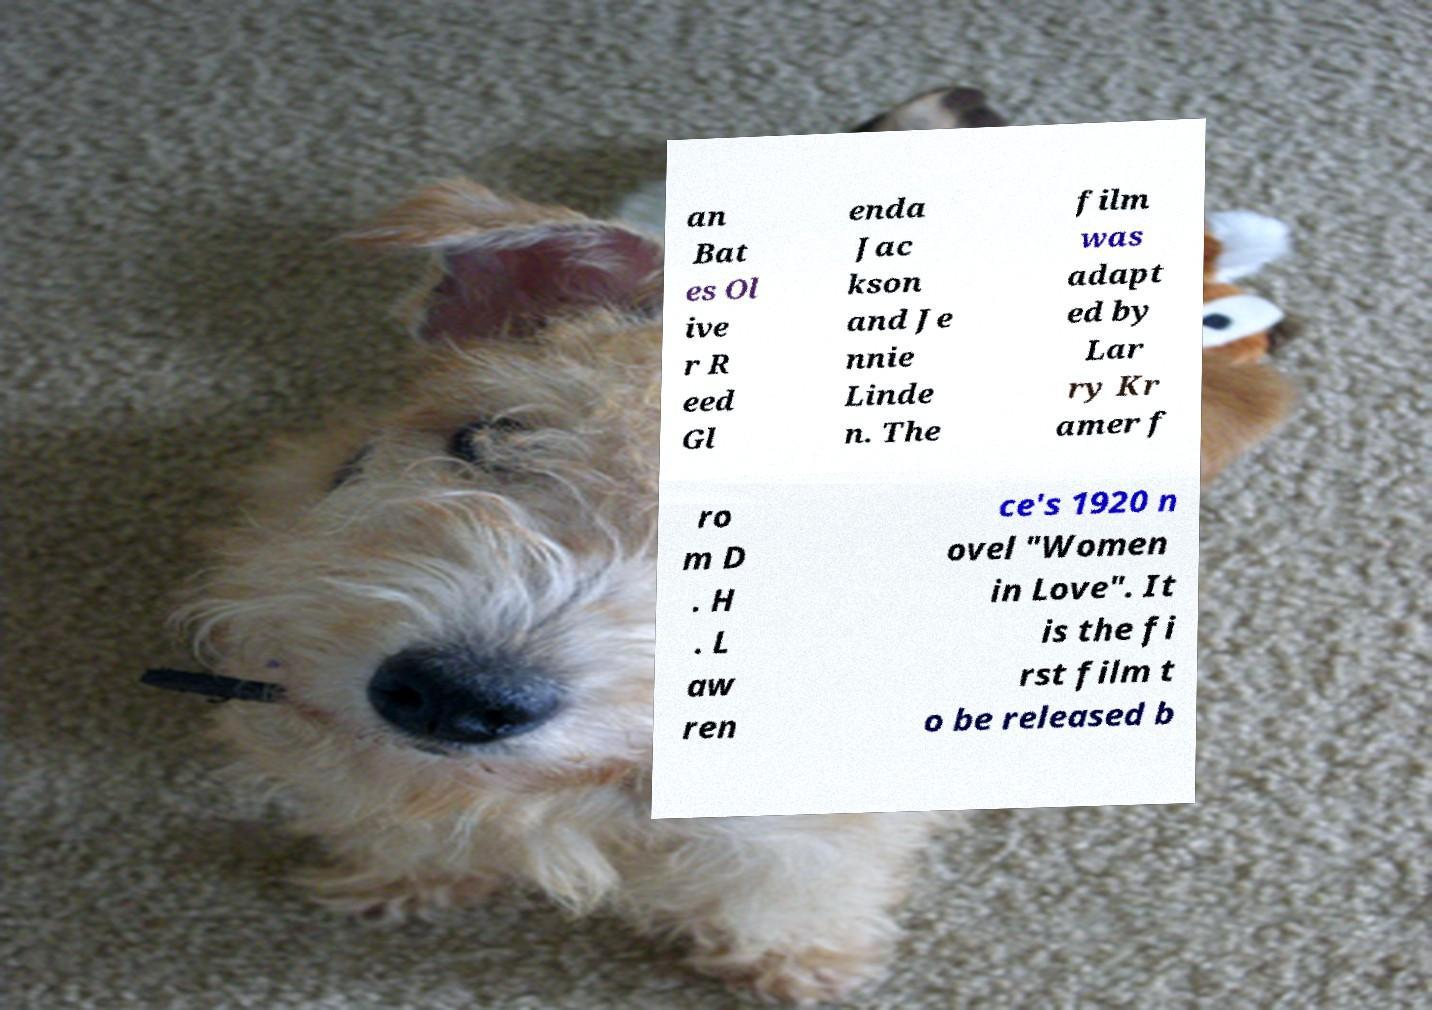Please identify and transcribe the text found in this image. an Bat es Ol ive r R eed Gl enda Jac kson and Je nnie Linde n. The film was adapt ed by Lar ry Kr amer f ro m D . H . L aw ren ce's 1920 n ovel "Women in Love". It is the fi rst film t o be released b 